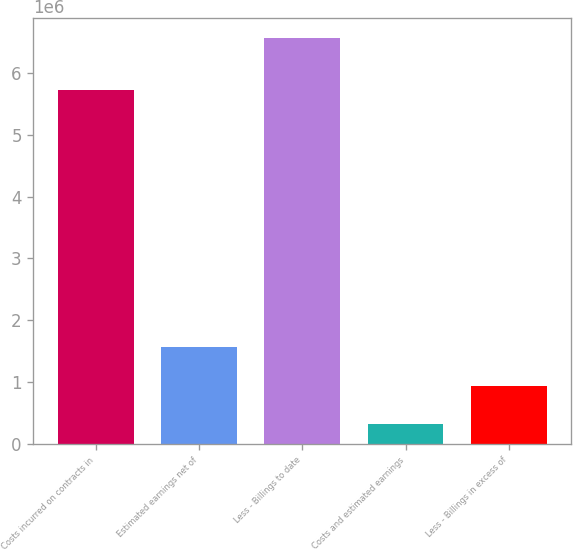<chart> <loc_0><loc_0><loc_500><loc_500><bar_chart><fcel>Costs incurred on contracts in<fcel>Estimated earnings net of<fcel>Less - Billings to date<fcel>Costs and estimated earnings<fcel>Less - Billings in excess of<nl><fcel>5.72508e+06<fcel>1.5669e+06<fcel>6.56354e+06<fcel>317745<fcel>942324<nl></chart> 